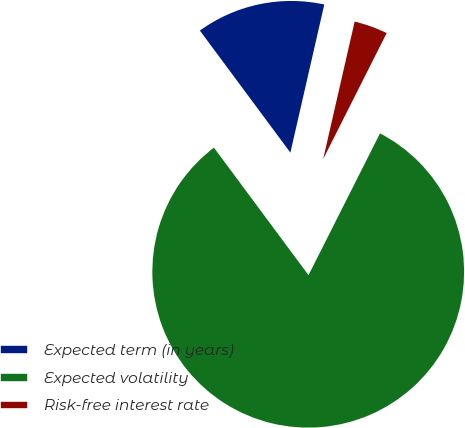Convert chart. <chart><loc_0><loc_0><loc_500><loc_500><pie_chart><fcel>Expected term (in years)<fcel>Expected volatility<fcel>Risk-free interest rate<nl><fcel>13.74%<fcel>82.42%<fcel>3.85%<nl></chart> 